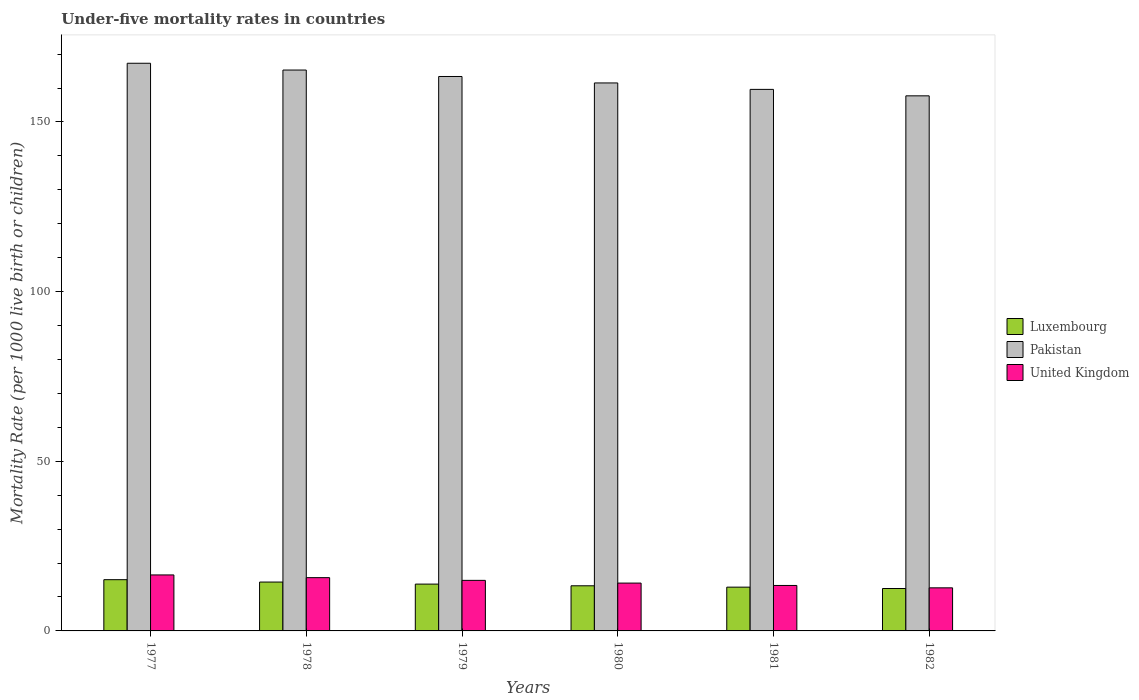How many different coloured bars are there?
Your answer should be very brief. 3. How many groups of bars are there?
Provide a short and direct response. 6. Are the number of bars on each tick of the X-axis equal?
Provide a succinct answer. Yes. How many bars are there on the 5th tick from the right?
Offer a terse response. 3. What is the label of the 3rd group of bars from the left?
Keep it short and to the point. 1979. What is the under-five mortality rate in United Kingdom in 1979?
Make the answer very short. 14.9. Across all years, what is the maximum under-five mortality rate in Pakistan?
Provide a succinct answer. 167.3. Across all years, what is the minimum under-five mortality rate in United Kingdom?
Give a very brief answer. 12.7. In which year was the under-five mortality rate in Pakistan maximum?
Your answer should be very brief. 1977. What is the total under-five mortality rate in United Kingdom in the graph?
Provide a succinct answer. 87.3. What is the difference between the under-five mortality rate in Pakistan in 1979 and that in 1980?
Keep it short and to the point. 1.9. What is the difference between the under-five mortality rate in Pakistan in 1978 and the under-five mortality rate in Luxembourg in 1980?
Give a very brief answer. 152. What is the average under-five mortality rate in Luxembourg per year?
Make the answer very short. 13.67. In the year 1982, what is the difference between the under-five mortality rate in Luxembourg and under-five mortality rate in United Kingdom?
Give a very brief answer. -0.2. What is the ratio of the under-five mortality rate in United Kingdom in 1977 to that in 1980?
Offer a very short reply. 1.17. Is the under-five mortality rate in Pakistan in 1978 less than that in 1979?
Your answer should be compact. No. Is the difference between the under-five mortality rate in Luxembourg in 1977 and 1982 greater than the difference between the under-five mortality rate in United Kingdom in 1977 and 1982?
Your answer should be compact. No. What is the difference between the highest and the second highest under-five mortality rate in Pakistan?
Give a very brief answer. 2. What is the difference between the highest and the lowest under-five mortality rate in Pakistan?
Offer a very short reply. 9.6. Is the sum of the under-five mortality rate in Luxembourg in 1979 and 1982 greater than the maximum under-five mortality rate in Pakistan across all years?
Give a very brief answer. No. What does the 3rd bar from the right in 1979 represents?
Keep it short and to the point. Luxembourg. Does the graph contain any zero values?
Ensure brevity in your answer.  No. Where does the legend appear in the graph?
Your answer should be very brief. Center right. How many legend labels are there?
Provide a succinct answer. 3. How are the legend labels stacked?
Offer a terse response. Vertical. What is the title of the graph?
Keep it short and to the point. Under-five mortality rates in countries. What is the label or title of the Y-axis?
Provide a short and direct response. Mortality Rate (per 1000 live birth or children). What is the Mortality Rate (per 1000 live birth or children) of Pakistan in 1977?
Ensure brevity in your answer.  167.3. What is the Mortality Rate (per 1000 live birth or children) of United Kingdom in 1977?
Give a very brief answer. 16.5. What is the Mortality Rate (per 1000 live birth or children) in Luxembourg in 1978?
Ensure brevity in your answer.  14.4. What is the Mortality Rate (per 1000 live birth or children) in Pakistan in 1978?
Provide a succinct answer. 165.3. What is the Mortality Rate (per 1000 live birth or children) of Luxembourg in 1979?
Give a very brief answer. 13.8. What is the Mortality Rate (per 1000 live birth or children) in Pakistan in 1979?
Offer a terse response. 163.4. What is the Mortality Rate (per 1000 live birth or children) of United Kingdom in 1979?
Make the answer very short. 14.9. What is the Mortality Rate (per 1000 live birth or children) in Luxembourg in 1980?
Give a very brief answer. 13.3. What is the Mortality Rate (per 1000 live birth or children) in Pakistan in 1980?
Offer a terse response. 161.5. What is the Mortality Rate (per 1000 live birth or children) in United Kingdom in 1980?
Your response must be concise. 14.1. What is the Mortality Rate (per 1000 live birth or children) of Pakistan in 1981?
Ensure brevity in your answer.  159.6. What is the Mortality Rate (per 1000 live birth or children) in Pakistan in 1982?
Your answer should be compact. 157.7. Across all years, what is the maximum Mortality Rate (per 1000 live birth or children) of Pakistan?
Your response must be concise. 167.3. Across all years, what is the maximum Mortality Rate (per 1000 live birth or children) of United Kingdom?
Your response must be concise. 16.5. Across all years, what is the minimum Mortality Rate (per 1000 live birth or children) in Pakistan?
Provide a succinct answer. 157.7. What is the total Mortality Rate (per 1000 live birth or children) in Pakistan in the graph?
Make the answer very short. 974.8. What is the total Mortality Rate (per 1000 live birth or children) in United Kingdom in the graph?
Ensure brevity in your answer.  87.3. What is the difference between the Mortality Rate (per 1000 live birth or children) of Pakistan in 1977 and that in 1978?
Provide a short and direct response. 2. What is the difference between the Mortality Rate (per 1000 live birth or children) in Luxembourg in 1977 and that in 1979?
Your answer should be compact. 1.3. What is the difference between the Mortality Rate (per 1000 live birth or children) in United Kingdom in 1977 and that in 1979?
Your answer should be compact. 1.6. What is the difference between the Mortality Rate (per 1000 live birth or children) in Luxembourg in 1977 and that in 1980?
Your answer should be very brief. 1.8. What is the difference between the Mortality Rate (per 1000 live birth or children) of Pakistan in 1977 and that in 1980?
Provide a succinct answer. 5.8. What is the difference between the Mortality Rate (per 1000 live birth or children) of United Kingdom in 1977 and that in 1980?
Provide a succinct answer. 2.4. What is the difference between the Mortality Rate (per 1000 live birth or children) of Luxembourg in 1977 and that in 1981?
Offer a terse response. 2.2. What is the difference between the Mortality Rate (per 1000 live birth or children) in Pakistan in 1977 and that in 1981?
Ensure brevity in your answer.  7.7. What is the difference between the Mortality Rate (per 1000 live birth or children) in United Kingdom in 1977 and that in 1981?
Provide a succinct answer. 3.1. What is the difference between the Mortality Rate (per 1000 live birth or children) in Luxembourg in 1977 and that in 1982?
Your answer should be compact. 2.6. What is the difference between the Mortality Rate (per 1000 live birth or children) of Pakistan in 1977 and that in 1982?
Provide a short and direct response. 9.6. What is the difference between the Mortality Rate (per 1000 live birth or children) in Luxembourg in 1978 and that in 1979?
Make the answer very short. 0.6. What is the difference between the Mortality Rate (per 1000 live birth or children) in Luxembourg in 1978 and that in 1980?
Offer a terse response. 1.1. What is the difference between the Mortality Rate (per 1000 live birth or children) of United Kingdom in 1978 and that in 1981?
Provide a succinct answer. 2.3. What is the difference between the Mortality Rate (per 1000 live birth or children) in Pakistan in 1978 and that in 1982?
Offer a terse response. 7.6. What is the difference between the Mortality Rate (per 1000 live birth or children) of United Kingdom in 1978 and that in 1982?
Your response must be concise. 3. What is the difference between the Mortality Rate (per 1000 live birth or children) in Pakistan in 1979 and that in 1980?
Provide a short and direct response. 1.9. What is the difference between the Mortality Rate (per 1000 live birth or children) of Luxembourg in 1979 and that in 1981?
Your answer should be very brief. 0.9. What is the difference between the Mortality Rate (per 1000 live birth or children) in Luxembourg in 1979 and that in 1982?
Offer a very short reply. 1.3. What is the difference between the Mortality Rate (per 1000 live birth or children) of Pakistan in 1979 and that in 1982?
Provide a short and direct response. 5.7. What is the difference between the Mortality Rate (per 1000 live birth or children) in United Kingdom in 1979 and that in 1982?
Offer a very short reply. 2.2. What is the difference between the Mortality Rate (per 1000 live birth or children) in Luxembourg in 1980 and that in 1981?
Your response must be concise. 0.4. What is the difference between the Mortality Rate (per 1000 live birth or children) of Pakistan in 1980 and that in 1981?
Ensure brevity in your answer.  1.9. What is the difference between the Mortality Rate (per 1000 live birth or children) of Luxembourg in 1980 and that in 1982?
Ensure brevity in your answer.  0.8. What is the difference between the Mortality Rate (per 1000 live birth or children) in Pakistan in 1980 and that in 1982?
Offer a very short reply. 3.8. What is the difference between the Mortality Rate (per 1000 live birth or children) in Luxembourg in 1981 and that in 1982?
Ensure brevity in your answer.  0.4. What is the difference between the Mortality Rate (per 1000 live birth or children) in Pakistan in 1981 and that in 1982?
Give a very brief answer. 1.9. What is the difference between the Mortality Rate (per 1000 live birth or children) of United Kingdom in 1981 and that in 1982?
Offer a very short reply. 0.7. What is the difference between the Mortality Rate (per 1000 live birth or children) in Luxembourg in 1977 and the Mortality Rate (per 1000 live birth or children) in Pakistan in 1978?
Make the answer very short. -150.2. What is the difference between the Mortality Rate (per 1000 live birth or children) in Luxembourg in 1977 and the Mortality Rate (per 1000 live birth or children) in United Kingdom in 1978?
Your answer should be very brief. -0.6. What is the difference between the Mortality Rate (per 1000 live birth or children) of Pakistan in 1977 and the Mortality Rate (per 1000 live birth or children) of United Kingdom in 1978?
Your answer should be compact. 151.6. What is the difference between the Mortality Rate (per 1000 live birth or children) in Luxembourg in 1977 and the Mortality Rate (per 1000 live birth or children) in Pakistan in 1979?
Ensure brevity in your answer.  -148.3. What is the difference between the Mortality Rate (per 1000 live birth or children) in Pakistan in 1977 and the Mortality Rate (per 1000 live birth or children) in United Kingdom in 1979?
Keep it short and to the point. 152.4. What is the difference between the Mortality Rate (per 1000 live birth or children) of Luxembourg in 1977 and the Mortality Rate (per 1000 live birth or children) of Pakistan in 1980?
Make the answer very short. -146.4. What is the difference between the Mortality Rate (per 1000 live birth or children) in Luxembourg in 1977 and the Mortality Rate (per 1000 live birth or children) in United Kingdom in 1980?
Your answer should be compact. 1. What is the difference between the Mortality Rate (per 1000 live birth or children) in Pakistan in 1977 and the Mortality Rate (per 1000 live birth or children) in United Kingdom in 1980?
Provide a short and direct response. 153.2. What is the difference between the Mortality Rate (per 1000 live birth or children) in Luxembourg in 1977 and the Mortality Rate (per 1000 live birth or children) in Pakistan in 1981?
Ensure brevity in your answer.  -144.5. What is the difference between the Mortality Rate (per 1000 live birth or children) of Luxembourg in 1977 and the Mortality Rate (per 1000 live birth or children) of United Kingdom in 1981?
Keep it short and to the point. 1.7. What is the difference between the Mortality Rate (per 1000 live birth or children) of Pakistan in 1977 and the Mortality Rate (per 1000 live birth or children) of United Kingdom in 1981?
Give a very brief answer. 153.9. What is the difference between the Mortality Rate (per 1000 live birth or children) of Luxembourg in 1977 and the Mortality Rate (per 1000 live birth or children) of Pakistan in 1982?
Make the answer very short. -142.6. What is the difference between the Mortality Rate (per 1000 live birth or children) of Luxembourg in 1977 and the Mortality Rate (per 1000 live birth or children) of United Kingdom in 1982?
Make the answer very short. 2.4. What is the difference between the Mortality Rate (per 1000 live birth or children) of Pakistan in 1977 and the Mortality Rate (per 1000 live birth or children) of United Kingdom in 1982?
Provide a short and direct response. 154.6. What is the difference between the Mortality Rate (per 1000 live birth or children) of Luxembourg in 1978 and the Mortality Rate (per 1000 live birth or children) of Pakistan in 1979?
Give a very brief answer. -149. What is the difference between the Mortality Rate (per 1000 live birth or children) of Pakistan in 1978 and the Mortality Rate (per 1000 live birth or children) of United Kingdom in 1979?
Provide a short and direct response. 150.4. What is the difference between the Mortality Rate (per 1000 live birth or children) in Luxembourg in 1978 and the Mortality Rate (per 1000 live birth or children) in Pakistan in 1980?
Your answer should be very brief. -147.1. What is the difference between the Mortality Rate (per 1000 live birth or children) in Pakistan in 1978 and the Mortality Rate (per 1000 live birth or children) in United Kingdom in 1980?
Offer a very short reply. 151.2. What is the difference between the Mortality Rate (per 1000 live birth or children) in Luxembourg in 1978 and the Mortality Rate (per 1000 live birth or children) in Pakistan in 1981?
Make the answer very short. -145.2. What is the difference between the Mortality Rate (per 1000 live birth or children) in Luxembourg in 1978 and the Mortality Rate (per 1000 live birth or children) in United Kingdom in 1981?
Give a very brief answer. 1. What is the difference between the Mortality Rate (per 1000 live birth or children) of Pakistan in 1978 and the Mortality Rate (per 1000 live birth or children) of United Kingdom in 1981?
Offer a terse response. 151.9. What is the difference between the Mortality Rate (per 1000 live birth or children) of Luxembourg in 1978 and the Mortality Rate (per 1000 live birth or children) of Pakistan in 1982?
Make the answer very short. -143.3. What is the difference between the Mortality Rate (per 1000 live birth or children) in Pakistan in 1978 and the Mortality Rate (per 1000 live birth or children) in United Kingdom in 1982?
Your answer should be very brief. 152.6. What is the difference between the Mortality Rate (per 1000 live birth or children) of Luxembourg in 1979 and the Mortality Rate (per 1000 live birth or children) of Pakistan in 1980?
Offer a terse response. -147.7. What is the difference between the Mortality Rate (per 1000 live birth or children) of Luxembourg in 1979 and the Mortality Rate (per 1000 live birth or children) of United Kingdom in 1980?
Make the answer very short. -0.3. What is the difference between the Mortality Rate (per 1000 live birth or children) of Pakistan in 1979 and the Mortality Rate (per 1000 live birth or children) of United Kingdom in 1980?
Ensure brevity in your answer.  149.3. What is the difference between the Mortality Rate (per 1000 live birth or children) in Luxembourg in 1979 and the Mortality Rate (per 1000 live birth or children) in Pakistan in 1981?
Make the answer very short. -145.8. What is the difference between the Mortality Rate (per 1000 live birth or children) of Luxembourg in 1979 and the Mortality Rate (per 1000 live birth or children) of United Kingdom in 1981?
Offer a terse response. 0.4. What is the difference between the Mortality Rate (per 1000 live birth or children) in Pakistan in 1979 and the Mortality Rate (per 1000 live birth or children) in United Kingdom in 1981?
Make the answer very short. 150. What is the difference between the Mortality Rate (per 1000 live birth or children) of Luxembourg in 1979 and the Mortality Rate (per 1000 live birth or children) of Pakistan in 1982?
Provide a short and direct response. -143.9. What is the difference between the Mortality Rate (per 1000 live birth or children) of Luxembourg in 1979 and the Mortality Rate (per 1000 live birth or children) of United Kingdom in 1982?
Your answer should be very brief. 1.1. What is the difference between the Mortality Rate (per 1000 live birth or children) of Pakistan in 1979 and the Mortality Rate (per 1000 live birth or children) of United Kingdom in 1982?
Your answer should be compact. 150.7. What is the difference between the Mortality Rate (per 1000 live birth or children) of Luxembourg in 1980 and the Mortality Rate (per 1000 live birth or children) of Pakistan in 1981?
Offer a very short reply. -146.3. What is the difference between the Mortality Rate (per 1000 live birth or children) in Luxembourg in 1980 and the Mortality Rate (per 1000 live birth or children) in United Kingdom in 1981?
Provide a short and direct response. -0.1. What is the difference between the Mortality Rate (per 1000 live birth or children) of Pakistan in 1980 and the Mortality Rate (per 1000 live birth or children) of United Kingdom in 1981?
Your answer should be compact. 148.1. What is the difference between the Mortality Rate (per 1000 live birth or children) of Luxembourg in 1980 and the Mortality Rate (per 1000 live birth or children) of Pakistan in 1982?
Offer a terse response. -144.4. What is the difference between the Mortality Rate (per 1000 live birth or children) in Luxembourg in 1980 and the Mortality Rate (per 1000 live birth or children) in United Kingdom in 1982?
Provide a short and direct response. 0.6. What is the difference between the Mortality Rate (per 1000 live birth or children) of Pakistan in 1980 and the Mortality Rate (per 1000 live birth or children) of United Kingdom in 1982?
Make the answer very short. 148.8. What is the difference between the Mortality Rate (per 1000 live birth or children) of Luxembourg in 1981 and the Mortality Rate (per 1000 live birth or children) of Pakistan in 1982?
Provide a short and direct response. -144.8. What is the difference between the Mortality Rate (per 1000 live birth or children) of Pakistan in 1981 and the Mortality Rate (per 1000 live birth or children) of United Kingdom in 1982?
Your answer should be very brief. 146.9. What is the average Mortality Rate (per 1000 live birth or children) in Luxembourg per year?
Offer a terse response. 13.67. What is the average Mortality Rate (per 1000 live birth or children) in Pakistan per year?
Your answer should be compact. 162.47. What is the average Mortality Rate (per 1000 live birth or children) of United Kingdom per year?
Offer a very short reply. 14.55. In the year 1977, what is the difference between the Mortality Rate (per 1000 live birth or children) of Luxembourg and Mortality Rate (per 1000 live birth or children) of Pakistan?
Ensure brevity in your answer.  -152.2. In the year 1977, what is the difference between the Mortality Rate (per 1000 live birth or children) of Pakistan and Mortality Rate (per 1000 live birth or children) of United Kingdom?
Offer a very short reply. 150.8. In the year 1978, what is the difference between the Mortality Rate (per 1000 live birth or children) in Luxembourg and Mortality Rate (per 1000 live birth or children) in Pakistan?
Your answer should be compact. -150.9. In the year 1978, what is the difference between the Mortality Rate (per 1000 live birth or children) of Luxembourg and Mortality Rate (per 1000 live birth or children) of United Kingdom?
Offer a very short reply. -1.3. In the year 1978, what is the difference between the Mortality Rate (per 1000 live birth or children) in Pakistan and Mortality Rate (per 1000 live birth or children) in United Kingdom?
Make the answer very short. 149.6. In the year 1979, what is the difference between the Mortality Rate (per 1000 live birth or children) of Luxembourg and Mortality Rate (per 1000 live birth or children) of Pakistan?
Offer a terse response. -149.6. In the year 1979, what is the difference between the Mortality Rate (per 1000 live birth or children) of Luxembourg and Mortality Rate (per 1000 live birth or children) of United Kingdom?
Your answer should be very brief. -1.1. In the year 1979, what is the difference between the Mortality Rate (per 1000 live birth or children) of Pakistan and Mortality Rate (per 1000 live birth or children) of United Kingdom?
Give a very brief answer. 148.5. In the year 1980, what is the difference between the Mortality Rate (per 1000 live birth or children) in Luxembourg and Mortality Rate (per 1000 live birth or children) in Pakistan?
Your answer should be very brief. -148.2. In the year 1980, what is the difference between the Mortality Rate (per 1000 live birth or children) in Luxembourg and Mortality Rate (per 1000 live birth or children) in United Kingdom?
Give a very brief answer. -0.8. In the year 1980, what is the difference between the Mortality Rate (per 1000 live birth or children) in Pakistan and Mortality Rate (per 1000 live birth or children) in United Kingdom?
Offer a very short reply. 147.4. In the year 1981, what is the difference between the Mortality Rate (per 1000 live birth or children) of Luxembourg and Mortality Rate (per 1000 live birth or children) of Pakistan?
Offer a very short reply. -146.7. In the year 1981, what is the difference between the Mortality Rate (per 1000 live birth or children) in Luxembourg and Mortality Rate (per 1000 live birth or children) in United Kingdom?
Offer a very short reply. -0.5. In the year 1981, what is the difference between the Mortality Rate (per 1000 live birth or children) in Pakistan and Mortality Rate (per 1000 live birth or children) in United Kingdom?
Your answer should be very brief. 146.2. In the year 1982, what is the difference between the Mortality Rate (per 1000 live birth or children) in Luxembourg and Mortality Rate (per 1000 live birth or children) in Pakistan?
Provide a succinct answer. -145.2. In the year 1982, what is the difference between the Mortality Rate (per 1000 live birth or children) in Pakistan and Mortality Rate (per 1000 live birth or children) in United Kingdom?
Your answer should be very brief. 145. What is the ratio of the Mortality Rate (per 1000 live birth or children) in Luxembourg in 1977 to that in 1978?
Give a very brief answer. 1.05. What is the ratio of the Mortality Rate (per 1000 live birth or children) of Pakistan in 1977 to that in 1978?
Your response must be concise. 1.01. What is the ratio of the Mortality Rate (per 1000 live birth or children) of United Kingdom in 1977 to that in 1978?
Provide a short and direct response. 1.05. What is the ratio of the Mortality Rate (per 1000 live birth or children) of Luxembourg in 1977 to that in 1979?
Offer a terse response. 1.09. What is the ratio of the Mortality Rate (per 1000 live birth or children) of Pakistan in 1977 to that in 1979?
Provide a succinct answer. 1.02. What is the ratio of the Mortality Rate (per 1000 live birth or children) in United Kingdom in 1977 to that in 1979?
Provide a succinct answer. 1.11. What is the ratio of the Mortality Rate (per 1000 live birth or children) in Luxembourg in 1977 to that in 1980?
Provide a short and direct response. 1.14. What is the ratio of the Mortality Rate (per 1000 live birth or children) in Pakistan in 1977 to that in 1980?
Your answer should be very brief. 1.04. What is the ratio of the Mortality Rate (per 1000 live birth or children) of United Kingdom in 1977 to that in 1980?
Make the answer very short. 1.17. What is the ratio of the Mortality Rate (per 1000 live birth or children) of Luxembourg in 1977 to that in 1981?
Provide a short and direct response. 1.17. What is the ratio of the Mortality Rate (per 1000 live birth or children) in Pakistan in 1977 to that in 1981?
Offer a very short reply. 1.05. What is the ratio of the Mortality Rate (per 1000 live birth or children) of United Kingdom in 1977 to that in 1981?
Make the answer very short. 1.23. What is the ratio of the Mortality Rate (per 1000 live birth or children) of Luxembourg in 1977 to that in 1982?
Keep it short and to the point. 1.21. What is the ratio of the Mortality Rate (per 1000 live birth or children) of Pakistan in 1977 to that in 1982?
Keep it short and to the point. 1.06. What is the ratio of the Mortality Rate (per 1000 live birth or children) in United Kingdom in 1977 to that in 1982?
Ensure brevity in your answer.  1.3. What is the ratio of the Mortality Rate (per 1000 live birth or children) in Luxembourg in 1978 to that in 1979?
Ensure brevity in your answer.  1.04. What is the ratio of the Mortality Rate (per 1000 live birth or children) of Pakistan in 1978 to that in 1979?
Ensure brevity in your answer.  1.01. What is the ratio of the Mortality Rate (per 1000 live birth or children) of United Kingdom in 1978 to that in 1979?
Make the answer very short. 1.05. What is the ratio of the Mortality Rate (per 1000 live birth or children) of Luxembourg in 1978 to that in 1980?
Your response must be concise. 1.08. What is the ratio of the Mortality Rate (per 1000 live birth or children) in Pakistan in 1978 to that in 1980?
Provide a succinct answer. 1.02. What is the ratio of the Mortality Rate (per 1000 live birth or children) in United Kingdom in 1978 to that in 1980?
Provide a short and direct response. 1.11. What is the ratio of the Mortality Rate (per 1000 live birth or children) in Luxembourg in 1978 to that in 1981?
Provide a succinct answer. 1.12. What is the ratio of the Mortality Rate (per 1000 live birth or children) of Pakistan in 1978 to that in 1981?
Offer a very short reply. 1.04. What is the ratio of the Mortality Rate (per 1000 live birth or children) in United Kingdom in 1978 to that in 1981?
Provide a succinct answer. 1.17. What is the ratio of the Mortality Rate (per 1000 live birth or children) in Luxembourg in 1978 to that in 1982?
Your answer should be compact. 1.15. What is the ratio of the Mortality Rate (per 1000 live birth or children) of Pakistan in 1978 to that in 1982?
Provide a succinct answer. 1.05. What is the ratio of the Mortality Rate (per 1000 live birth or children) of United Kingdom in 1978 to that in 1982?
Keep it short and to the point. 1.24. What is the ratio of the Mortality Rate (per 1000 live birth or children) in Luxembourg in 1979 to that in 1980?
Provide a succinct answer. 1.04. What is the ratio of the Mortality Rate (per 1000 live birth or children) of Pakistan in 1979 to that in 1980?
Your response must be concise. 1.01. What is the ratio of the Mortality Rate (per 1000 live birth or children) in United Kingdom in 1979 to that in 1980?
Keep it short and to the point. 1.06. What is the ratio of the Mortality Rate (per 1000 live birth or children) of Luxembourg in 1979 to that in 1981?
Give a very brief answer. 1.07. What is the ratio of the Mortality Rate (per 1000 live birth or children) in Pakistan in 1979 to that in 1981?
Provide a succinct answer. 1.02. What is the ratio of the Mortality Rate (per 1000 live birth or children) of United Kingdom in 1979 to that in 1981?
Your answer should be compact. 1.11. What is the ratio of the Mortality Rate (per 1000 live birth or children) in Luxembourg in 1979 to that in 1982?
Offer a very short reply. 1.1. What is the ratio of the Mortality Rate (per 1000 live birth or children) of Pakistan in 1979 to that in 1982?
Offer a terse response. 1.04. What is the ratio of the Mortality Rate (per 1000 live birth or children) of United Kingdom in 1979 to that in 1982?
Your answer should be very brief. 1.17. What is the ratio of the Mortality Rate (per 1000 live birth or children) in Luxembourg in 1980 to that in 1981?
Your answer should be very brief. 1.03. What is the ratio of the Mortality Rate (per 1000 live birth or children) of Pakistan in 1980 to that in 1981?
Your response must be concise. 1.01. What is the ratio of the Mortality Rate (per 1000 live birth or children) of United Kingdom in 1980 to that in 1981?
Ensure brevity in your answer.  1.05. What is the ratio of the Mortality Rate (per 1000 live birth or children) of Luxembourg in 1980 to that in 1982?
Your response must be concise. 1.06. What is the ratio of the Mortality Rate (per 1000 live birth or children) in Pakistan in 1980 to that in 1982?
Provide a succinct answer. 1.02. What is the ratio of the Mortality Rate (per 1000 live birth or children) in United Kingdom in 1980 to that in 1982?
Offer a terse response. 1.11. What is the ratio of the Mortality Rate (per 1000 live birth or children) of Luxembourg in 1981 to that in 1982?
Your response must be concise. 1.03. What is the ratio of the Mortality Rate (per 1000 live birth or children) in Pakistan in 1981 to that in 1982?
Ensure brevity in your answer.  1.01. What is the ratio of the Mortality Rate (per 1000 live birth or children) of United Kingdom in 1981 to that in 1982?
Make the answer very short. 1.06. What is the difference between the highest and the second highest Mortality Rate (per 1000 live birth or children) in Luxembourg?
Offer a very short reply. 0.7. What is the difference between the highest and the second highest Mortality Rate (per 1000 live birth or children) in Pakistan?
Your response must be concise. 2. What is the difference between the highest and the lowest Mortality Rate (per 1000 live birth or children) of Luxembourg?
Make the answer very short. 2.6. 